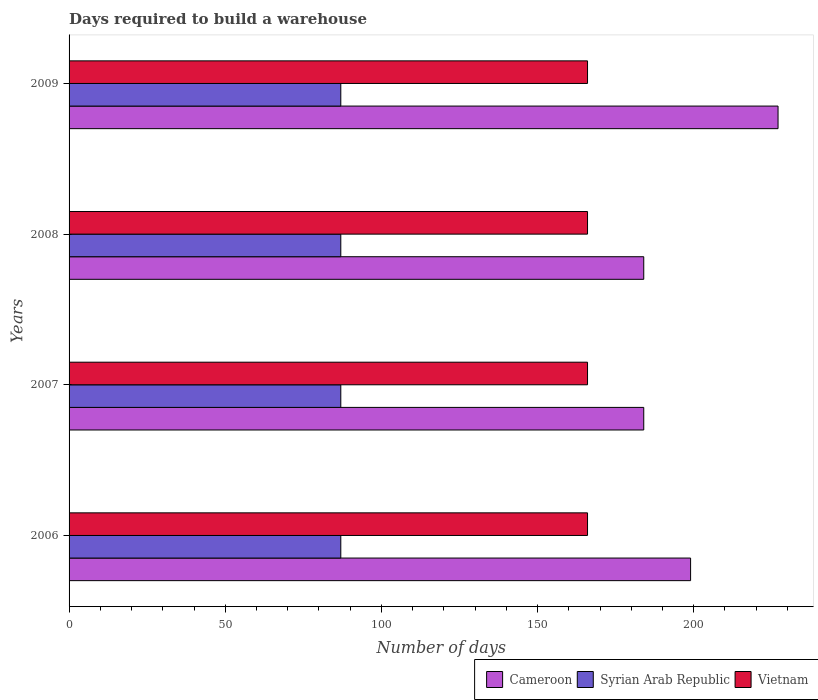How many groups of bars are there?
Offer a terse response. 4. Are the number of bars per tick equal to the number of legend labels?
Your answer should be compact. Yes. How many bars are there on the 4th tick from the top?
Your response must be concise. 3. What is the days required to build a warehouse in in Syrian Arab Republic in 2007?
Make the answer very short. 87. Across all years, what is the maximum days required to build a warehouse in in Cameroon?
Provide a short and direct response. 227. Across all years, what is the minimum days required to build a warehouse in in Cameroon?
Make the answer very short. 184. In which year was the days required to build a warehouse in in Vietnam maximum?
Your answer should be very brief. 2006. What is the total days required to build a warehouse in in Vietnam in the graph?
Offer a terse response. 664. What is the difference between the days required to build a warehouse in in Cameroon in 2006 and the days required to build a warehouse in in Vietnam in 2009?
Provide a succinct answer. 33. What is the average days required to build a warehouse in in Vietnam per year?
Your response must be concise. 166. In the year 2006, what is the difference between the days required to build a warehouse in in Vietnam and days required to build a warehouse in in Cameroon?
Your answer should be compact. -33. In how many years, is the days required to build a warehouse in in Cameroon greater than 160 days?
Make the answer very short. 4. What is the ratio of the days required to build a warehouse in in Cameroon in 2008 to that in 2009?
Make the answer very short. 0.81. Is the days required to build a warehouse in in Cameroon in 2007 less than that in 2009?
Ensure brevity in your answer.  Yes. Is the difference between the days required to build a warehouse in in Vietnam in 2006 and 2007 greater than the difference between the days required to build a warehouse in in Cameroon in 2006 and 2007?
Ensure brevity in your answer.  No. What is the difference between the highest and the lowest days required to build a warehouse in in Cameroon?
Make the answer very short. 43. In how many years, is the days required to build a warehouse in in Vietnam greater than the average days required to build a warehouse in in Vietnam taken over all years?
Ensure brevity in your answer.  0. Is the sum of the days required to build a warehouse in in Cameroon in 2007 and 2009 greater than the maximum days required to build a warehouse in in Vietnam across all years?
Your answer should be very brief. Yes. What does the 2nd bar from the top in 2008 represents?
Your answer should be compact. Syrian Arab Republic. What does the 2nd bar from the bottom in 2009 represents?
Offer a very short reply. Syrian Arab Republic. Are all the bars in the graph horizontal?
Offer a terse response. Yes. How many years are there in the graph?
Keep it short and to the point. 4. What is the difference between two consecutive major ticks on the X-axis?
Provide a succinct answer. 50. Does the graph contain grids?
Your response must be concise. No. How many legend labels are there?
Make the answer very short. 3. What is the title of the graph?
Give a very brief answer. Days required to build a warehouse. What is the label or title of the X-axis?
Offer a terse response. Number of days. What is the label or title of the Y-axis?
Your response must be concise. Years. What is the Number of days of Cameroon in 2006?
Offer a terse response. 199. What is the Number of days of Vietnam in 2006?
Provide a succinct answer. 166. What is the Number of days in Cameroon in 2007?
Provide a succinct answer. 184. What is the Number of days in Syrian Arab Republic in 2007?
Offer a terse response. 87. What is the Number of days of Vietnam in 2007?
Your answer should be compact. 166. What is the Number of days in Cameroon in 2008?
Offer a terse response. 184. What is the Number of days in Syrian Arab Republic in 2008?
Give a very brief answer. 87. What is the Number of days in Vietnam in 2008?
Provide a succinct answer. 166. What is the Number of days in Cameroon in 2009?
Your answer should be very brief. 227. What is the Number of days in Vietnam in 2009?
Offer a terse response. 166. Across all years, what is the maximum Number of days of Cameroon?
Make the answer very short. 227. Across all years, what is the maximum Number of days of Vietnam?
Ensure brevity in your answer.  166. Across all years, what is the minimum Number of days in Cameroon?
Your answer should be very brief. 184. Across all years, what is the minimum Number of days in Vietnam?
Keep it short and to the point. 166. What is the total Number of days in Cameroon in the graph?
Your answer should be very brief. 794. What is the total Number of days in Syrian Arab Republic in the graph?
Your answer should be compact. 348. What is the total Number of days in Vietnam in the graph?
Give a very brief answer. 664. What is the difference between the Number of days in Vietnam in 2006 and that in 2007?
Ensure brevity in your answer.  0. What is the difference between the Number of days in Cameroon in 2006 and that in 2008?
Your answer should be compact. 15. What is the difference between the Number of days in Vietnam in 2006 and that in 2008?
Give a very brief answer. 0. What is the difference between the Number of days in Syrian Arab Republic in 2006 and that in 2009?
Offer a very short reply. 0. What is the difference between the Number of days of Vietnam in 2006 and that in 2009?
Provide a succinct answer. 0. What is the difference between the Number of days of Cameroon in 2007 and that in 2008?
Make the answer very short. 0. What is the difference between the Number of days in Cameroon in 2007 and that in 2009?
Your answer should be compact. -43. What is the difference between the Number of days of Cameroon in 2008 and that in 2009?
Make the answer very short. -43. What is the difference between the Number of days of Syrian Arab Republic in 2008 and that in 2009?
Ensure brevity in your answer.  0. What is the difference between the Number of days in Vietnam in 2008 and that in 2009?
Provide a succinct answer. 0. What is the difference between the Number of days of Cameroon in 2006 and the Number of days of Syrian Arab Republic in 2007?
Your response must be concise. 112. What is the difference between the Number of days of Cameroon in 2006 and the Number of days of Vietnam in 2007?
Your response must be concise. 33. What is the difference between the Number of days in Syrian Arab Republic in 2006 and the Number of days in Vietnam in 2007?
Offer a very short reply. -79. What is the difference between the Number of days in Cameroon in 2006 and the Number of days in Syrian Arab Republic in 2008?
Make the answer very short. 112. What is the difference between the Number of days in Syrian Arab Republic in 2006 and the Number of days in Vietnam in 2008?
Make the answer very short. -79. What is the difference between the Number of days in Cameroon in 2006 and the Number of days in Syrian Arab Republic in 2009?
Keep it short and to the point. 112. What is the difference between the Number of days of Syrian Arab Republic in 2006 and the Number of days of Vietnam in 2009?
Your answer should be very brief. -79. What is the difference between the Number of days in Cameroon in 2007 and the Number of days in Syrian Arab Republic in 2008?
Keep it short and to the point. 97. What is the difference between the Number of days in Cameroon in 2007 and the Number of days in Vietnam in 2008?
Your response must be concise. 18. What is the difference between the Number of days of Syrian Arab Republic in 2007 and the Number of days of Vietnam in 2008?
Keep it short and to the point. -79. What is the difference between the Number of days of Cameroon in 2007 and the Number of days of Syrian Arab Republic in 2009?
Your response must be concise. 97. What is the difference between the Number of days of Syrian Arab Republic in 2007 and the Number of days of Vietnam in 2009?
Give a very brief answer. -79. What is the difference between the Number of days in Cameroon in 2008 and the Number of days in Syrian Arab Republic in 2009?
Provide a short and direct response. 97. What is the difference between the Number of days in Cameroon in 2008 and the Number of days in Vietnam in 2009?
Keep it short and to the point. 18. What is the difference between the Number of days in Syrian Arab Republic in 2008 and the Number of days in Vietnam in 2009?
Provide a short and direct response. -79. What is the average Number of days in Cameroon per year?
Offer a terse response. 198.5. What is the average Number of days in Vietnam per year?
Your answer should be compact. 166. In the year 2006, what is the difference between the Number of days of Cameroon and Number of days of Syrian Arab Republic?
Your answer should be compact. 112. In the year 2006, what is the difference between the Number of days of Syrian Arab Republic and Number of days of Vietnam?
Ensure brevity in your answer.  -79. In the year 2007, what is the difference between the Number of days of Cameroon and Number of days of Syrian Arab Republic?
Ensure brevity in your answer.  97. In the year 2007, what is the difference between the Number of days of Cameroon and Number of days of Vietnam?
Ensure brevity in your answer.  18. In the year 2007, what is the difference between the Number of days in Syrian Arab Republic and Number of days in Vietnam?
Give a very brief answer. -79. In the year 2008, what is the difference between the Number of days of Cameroon and Number of days of Syrian Arab Republic?
Ensure brevity in your answer.  97. In the year 2008, what is the difference between the Number of days of Syrian Arab Republic and Number of days of Vietnam?
Ensure brevity in your answer.  -79. In the year 2009, what is the difference between the Number of days in Cameroon and Number of days in Syrian Arab Republic?
Offer a very short reply. 140. In the year 2009, what is the difference between the Number of days in Cameroon and Number of days in Vietnam?
Offer a terse response. 61. In the year 2009, what is the difference between the Number of days in Syrian Arab Republic and Number of days in Vietnam?
Your response must be concise. -79. What is the ratio of the Number of days of Cameroon in 2006 to that in 2007?
Your answer should be compact. 1.08. What is the ratio of the Number of days in Vietnam in 2006 to that in 2007?
Your answer should be very brief. 1. What is the ratio of the Number of days of Cameroon in 2006 to that in 2008?
Provide a succinct answer. 1.08. What is the ratio of the Number of days in Vietnam in 2006 to that in 2008?
Make the answer very short. 1. What is the ratio of the Number of days of Cameroon in 2006 to that in 2009?
Make the answer very short. 0.88. What is the ratio of the Number of days of Cameroon in 2007 to that in 2009?
Ensure brevity in your answer.  0.81. What is the ratio of the Number of days of Syrian Arab Republic in 2007 to that in 2009?
Your answer should be very brief. 1. What is the ratio of the Number of days of Cameroon in 2008 to that in 2009?
Your answer should be very brief. 0.81. What is the difference between the highest and the second highest Number of days in Cameroon?
Provide a short and direct response. 28. 